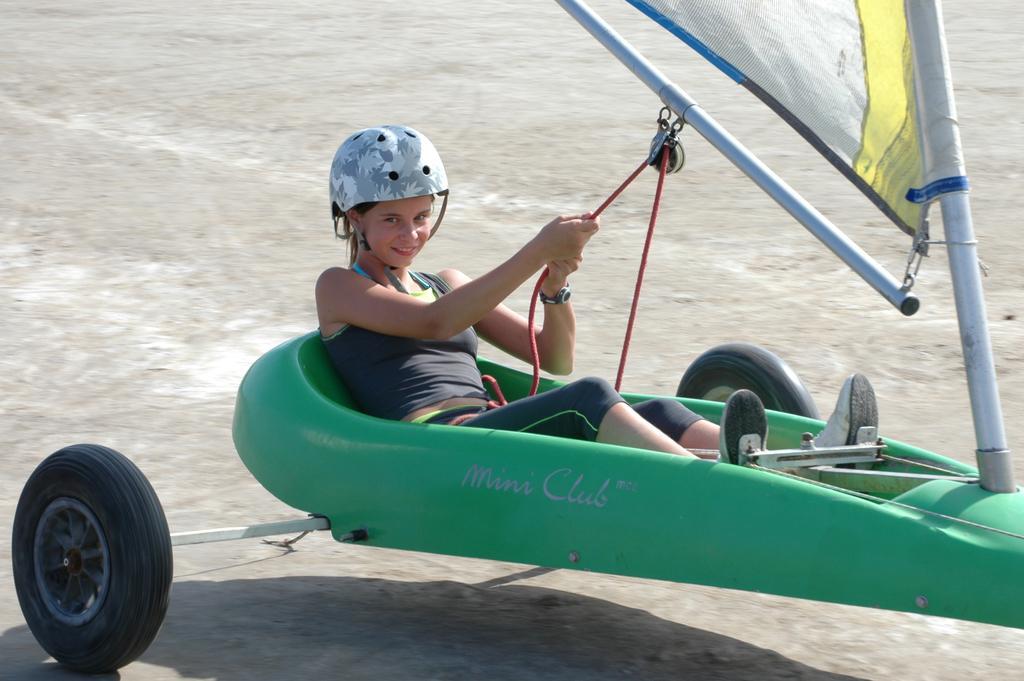In one or two sentences, can you explain what this image depicts? In this image in front there is a person on the land sailing. At the bottom of the image there is a road. 